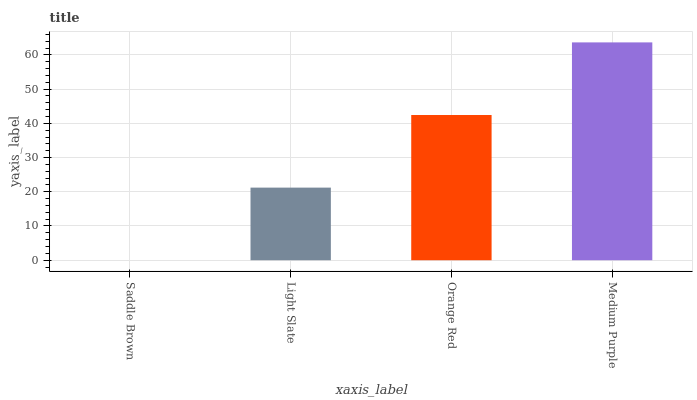Is Saddle Brown the minimum?
Answer yes or no. Yes. Is Medium Purple the maximum?
Answer yes or no. Yes. Is Light Slate the minimum?
Answer yes or no. No. Is Light Slate the maximum?
Answer yes or no. No. Is Light Slate greater than Saddle Brown?
Answer yes or no. Yes. Is Saddle Brown less than Light Slate?
Answer yes or no. Yes. Is Saddle Brown greater than Light Slate?
Answer yes or no. No. Is Light Slate less than Saddle Brown?
Answer yes or no. No. Is Orange Red the high median?
Answer yes or no. Yes. Is Light Slate the low median?
Answer yes or no. Yes. Is Medium Purple the high median?
Answer yes or no. No. Is Orange Red the low median?
Answer yes or no. No. 